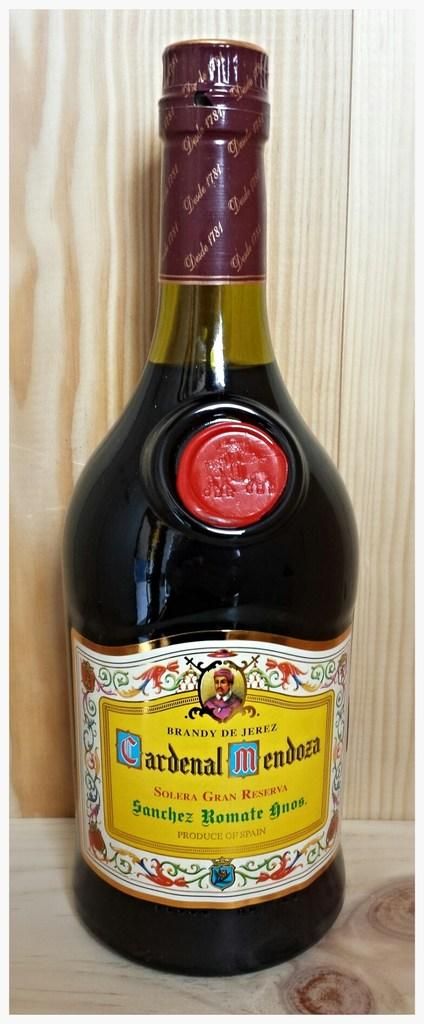<image>
Describe the image concisely. A sealed bottle of Cardenal Mendoza Solera Gran Reserva. 